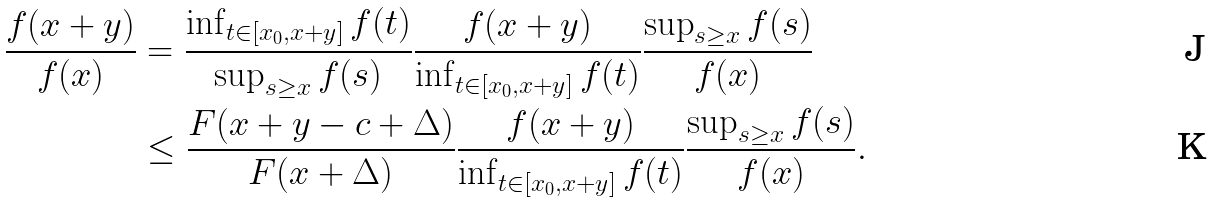<formula> <loc_0><loc_0><loc_500><loc_500>\frac { f ( x + y ) } { f ( x ) } & = \frac { \inf _ { t \in [ x _ { 0 } , x + y ] } f ( t ) } { \sup _ { s \geq x } f ( s ) } \frac { f ( x + y ) } { \inf _ { t \in [ x _ { 0 } , x + y ] } f ( t ) } \frac { \sup _ { s \geq x } f ( s ) } { f ( x ) } \\ & \leq \frac { F ( x + y - c + \Delta ) } { F ( x + \Delta ) } \frac { f ( x + y ) } { \inf _ { t \in [ x _ { 0 } , x + y ] } f ( t ) } \frac { \sup _ { s \geq x } f ( s ) } { f ( x ) } .</formula> 